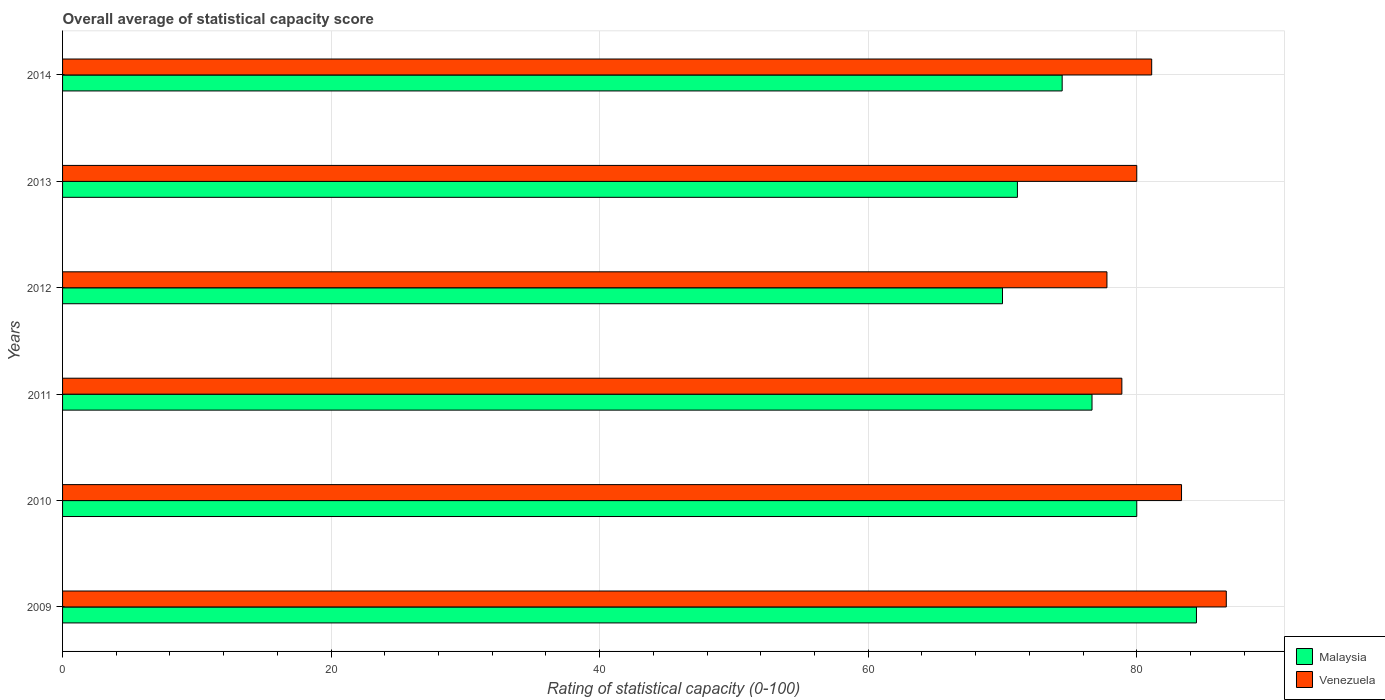How many different coloured bars are there?
Ensure brevity in your answer.  2. Are the number of bars per tick equal to the number of legend labels?
Make the answer very short. Yes. How many bars are there on the 3rd tick from the top?
Your response must be concise. 2. How many bars are there on the 2nd tick from the bottom?
Offer a very short reply. 2. What is the label of the 5th group of bars from the top?
Keep it short and to the point. 2010. What is the rating of statistical capacity in Venezuela in 2009?
Provide a short and direct response. 86.67. Across all years, what is the maximum rating of statistical capacity in Venezuela?
Offer a very short reply. 86.67. Across all years, what is the minimum rating of statistical capacity in Venezuela?
Make the answer very short. 77.78. In which year was the rating of statistical capacity in Malaysia minimum?
Offer a terse response. 2012. What is the total rating of statistical capacity in Venezuela in the graph?
Give a very brief answer. 487.78. What is the difference between the rating of statistical capacity in Malaysia in 2010 and that in 2013?
Keep it short and to the point. 8.89. What is the difference between the rating of statistical capacity in Venezuela in 2011 and the rating of statistical capacity in Malaysia in 2012?
Offer a terse response. 8.89. What is the average rating of statistical capacity in Venezuela per year?
Ensure brevity in your answer.  81.3. In the year 2010, what is the difference between the rating of statistical capacity in Malaysia and rating of statistical capacity in Venezuela?
Provide a short and direct response. -3.33. In how many years, is the rating of statistical capacity in Venezuela greater than 56 ?
Your answer should be compact. 6. What is the ratio of the rating of statistical capacity in Venezuela in 2010 to that in 2014?
Provide a succinct answer. 1.03. Is the rating of statistical capacity in Venezuela in 2010 less than that in 2014?
Offer a terse response. No. Is the difference between the rating of statistical capacity in Malaysia in 2011 and 2014 greater than the difference between the rating of statistical capacity in Venezuela in 2011 and 2014?
Ensure brevity in your answer.  Yes. What is the difference between the highest and the second highest rating of statistical capacity in Malaysia?
Your answer should be very brief. 4.44. What is the difference between the highest and the lowest rating of statistical capacity in Malaysia?
Your response must be concise. 14.44. Is the sum of the rating of statistical capacity in Venezuela in 2011 and 2013 greater than the maximum rating of statistical capacity in Malaysia across all years?
Provide a succinct answer. Yes. What does the 1st bar from the top in 2012 represents?
Give a very brief answer. Venezuela. What does the 1st bar from the bottom in 2013 represents?
Your answer should be compact. Malaysia. How many bars are there?
Provide a short and direct response. 12. Are all the bars in the graph horizontal?
Provide a succinct answer. Yes. How many years are there in the graph?
Offer a terse response. 6. Are the values on the major ticks of X-axis written in scientific E-notation?
Your answer should be very brief. No. Where does the legend appear in the graph?
Your response must be concise. Bottom right. What is the title of the graph?
Ensure brevity in your answer.  Overall average of statistical capacity score. Does "Cambodia" appear as one of the legend labels in the graph?
Your answer should be compact. No. What is the label or title of the X-axis?
Keep it short and to the point. Rating of statistical capacity (0-100). What is the label or title of the Y-axis?
Your response must be concise. Years. What is the Rating of statistical capacity (0-100) of Malaysia in 2009?
Your response must be concise. 84.44. What is the Rating of statistical capacity (0-100) in Venezuela in 2009?
Ensure brevity in your answer.  86.67. What is the Rating of statistical capacity (0-100) of Venezuela in 2010?
Your answer should be very brief. 83.33. What is the Rating of statistical capacity (0-100) of Malaysia in 2011?
Provide a short and direct response. 76.67. What is the Rating of statistical capacity (0-100) in Venezuela in 2011?
Keep it short and to the point. 78.89. What is the Rating of statistical capacity (0-100) in Malaysia in 2012?
Your answer should be very brief. 70. What is the Rating of statistical capacity (0-100) in Venezuela in 2012?
Your answer should be very brief. 77.78. What is the Rating of statistical capacity (0-100) of Malaysia in 2013?
Provide a succinct answer. 71.11. What is the Rating of statistical capacity (0-100) in Malaysia in 2014?
Your answer should be compact. 74.44. What is the Rating of statistical capacity (0-100) of Venezuela in 2014?
Your answer should be very brief. 81.11. Across all years, what is the maximum Rating of statistical capacity (0-100) of Malaysia?
Your answer should be very brief. 84.44. Across all years, what is the maximum Rating of statistical capacity (0-100) in Venezuela?
Your answer should be very brief. 86.67. Across all years, what is the minimum Rating of statistical capacity (0-100) of Malaysia?
Your response must be concise. 70. Across all years, what is the minimum Rating of statistical capacity (0-100) in Venezuela?
Make the answer very short. 77.78. What is the total Rating of statistical capacity (0-100) of Malaysia in the graph?
Offer a terse response. 456.67. What is the total Rating of statistical capacity (0-100) of Venezuela in the graph?
Provide a short and direct response. 487.78. What is the difference between the Rating of statistical capacity (0-100) in Malaysia in 2009 and that in 2010?
Offer a very short reply. 4.44. What is the difference between the Rating of statistical capacity (0-100) of Venezuela in 2009 and that in 2010?
Offer a terse response. 3.33. What is the difference between the Rating of statistical capacity (0-100) in Malaysia in 2009 and that in 2011?
Make the answer very short. 7.78. What is the difference between the Rating of statistical capacity (0-100) in Venezuela in 2009 and that in 2011?
Offer a terse response. 7.78. What is the difference between the Rating of statistical capacity (0-100) in Malaysia in 2009 and that in 2012?
Provide a succinct answer. 14.44. What is the difference between the Rating of statistical capacity (0-100) in Venezuela in 2009 and that in 2012?
Ensure brevity in your answer.  8.89. What is the difference between the Rating of statistical capacity (0-100) in Malaysia in 2009 and that in 2013?
Offer a very short reply. 13.33. What is the difference between the Rating of statistical capacity (0-100) in Venezuela in 2009 and that in 2013?
Offer a very short reply. 6.67. What is the difference between the Rating of statistical capacity (0-100) of Venezuela in 2009 and that in 2014?
Your response must be concise. 5.56. What is the difference between the Rating of statistical capacity (0-100) of Malaysia in 2010 and that in 2011?
Provide a short and direct response. 3.33. What is the difference between the Rating of statistical capacity (0-100) of Venezuela in 2010 and that in 2011?
Your response must be concise. 4.44. What is the difference between the Rating of statistical capacity (0-100) of Venezuela in 2010 and that in 2012?
Your answer should be compact. 5.56. What is the difference between the Rating of statistical capacity (0-100) in Malaysia in 2010 and that in 2013?
Keep it short and to the point. 8.89. What is the difference between the Rating of statistical capacity (0-100) in Malaysia in 2010 and that in 2014?
Offer a terse response. 5.56. What is the difference between the Rating of statistical capacity (0-100) of Venezuela in 2010 and that in 2014?
Ensure brevity in your answer.  2.22. What is the difference between the Rating of statistical capacity (0-100) of Venezuela in 2011 and that in 2012?
Keep it short and to the point. 1.11. What is the difference between the Rating of statistical capacity (0-100) of Malaysia in 2011 and that in 2013?
Give a very brief answer. 5.56. What is the difference between the Rating of statistical capacity (0-100) in Venezuela in 2011 and that in 2013?
Provide a short and direct response. -1.11. What is the difference between the Rating of statistical capacity (0-100) in Malaysia in 2011 and that in 2014?
Ensure brevity in your answer.  2.22. What is the difference between the Rating of statistical capacity (0-100) in Venezuela in 2011 and that in 2014?
Your answer should be very brief. -2.22. What is the difference between the Rating of statistical capacity (0-100) of Malaysia in 2012 and that in 2013?
Provide a succinct answer. -1.11. What is the difference between the Rating of statistical capacity (0-100) in Venezuela in 2012 and that in 2013?
Ensure brevity in your answer.  -2.22. What is the difference between the Rating of statistical capacity (0-100) of Malaysia in 2012 and that in 2014?
Keep it short and to the point. -4.44. What is the difference between the Rating of statistical capacity (0-100) in Malaysia in 2013 and that in 2014?
Give a very brief answer. -3.33. What is the difference between the Rating of statistical capacity (0-100) in Venezuela in 2013 and that in 2014?
Make the answer very short. -1.11. What is the difference between the Rating of statistical capacity (0-100) of Malaysia in 2009 and the Rating of statistical capacity (0-100) of Venezuela in 2011?
Ensure brevity in your answer.  5.56. What is the difference between the Rating of statistical capacity (0-100) in Malaysia in 2009 and the Rating of statistical capacity (0-100) in Venezuela in 2012?
Keep it short and to the point. 6.67. What is the difference between the Rating of statistical capacity (0-100) in Malaysia in 2009 and the Rating of statistical capacity (0-100) in Venezuela in 2013?
Make the answer very short. 4.44. What is the difference between the Rating of statistical capacity (0-100) of Malaysia in 2009 and the Rating of statistical capacity (0-100) of Venezuela in 2014?
Ensure brevity in your answer.  3.33. What is the difference between the Rating of statistical capacity (0-100) in Malaysia in 2010 and the Rating of statistical capacity (0-100) in Venezuela in 2011?
Keep it short and to the point. 1.11. What is the difference between the Rating of statistical capacity (0-100) in Malaysia in 2010 and the Rating of statistical capacity (0-100) in Venezuela in 2012?
Your answer should be compact. 2.22. What is the difference between the Rating of statistical capacity (0-100) in Malaysia in 2010 and the Rating of statistical capacity (0-100) in Venezuela in 2014?
Keep it short and to the point. -1.11. What is the difference between the Rating of statistical capacity (0-100) of Malaysia in 2011 and the Rating of statistical capacity (0-100) of Venezuela in 2012?
Make the answer very short. -1.11. What is the difference between the Rating of statistical capacity (0-100) in Malaysia in 2011 and the Rating of statistical capacity (0-100) in Venezuela in 2014?
Ensure brevity in your answer.  -4.44. What is the difference between the Rating of statistical capacity (0-100) in Malaysia in 2012 and the Rating of statistical capacity (0-100) in Venezuela in 2013?
Your response must be concise. -10. What is the difference between the Rating of statistical capacity (0-100) in Malaysia in 2012 and the Rating of statistical capacity (0-100) in Venezuela in 2014?
Provide a short and direct response. -11.11. What is the average Rating of statistical capacity (0-100) in Malaysia per year?
Your answer should be compact. 76.11. What is the average Rating of statistical capacity (0-100) in Venezuela per year?
Provide a succinct answer. 81.3. In the year 2009, what is the difference between the Rating of statistical capacity (0-100) of Malaysia and Rating of statistical capacity (0-100) of Venezuela?
Your answer should be very brief. -2.22. In the year 2010, what is the difference between the Rating of statistical capacity (0-100) of Malaysia and Rating of statistical capacity (0-100) of Venezuela?
Provide a succinct answer. -3.33. In the year 2011, what is the difference between the Rating of statistical capacity (0-100) in Malaysia and Rating of statistical capacity (0-100) in Venezuela?
Make the answer very short. -2.22. In the year 2012, what is the difference between the Rating of statistical capacity (0-100) in Malaysia and Rating of statistical capacity (0-100) in Venezuela?
Provide a succinct answer. -7.78. In the year 2013, what is the difference between the Rating of statistical capacity (0-100) in Malaysia and Rating of statistical capacity (0-100) in Venezuela?
Your answer should be very brief. -8.89. In the year 2014, what is the difference between the Rating of statistical capacity (0-100) of Malaysia and Rating of statistical capacity (0-100) of Venezuela?
Keep it short and to the point. -6.67. What is the ratio of the Rating of statistical capacity (0-100) of Malaysia in 2009 to that in 2010?
Offer a very short reply. 1.06. What is the ratio of the Rating of statistical capacity (0-100) in Venezuela in 2009 to that in 2010?
Provide a succinct answer. 1.04. What is the ratio of the Rating of statistical capacity (0-100) of Malaysia in 2009 to that in 2011?
Offer a very short reply. 1.1. What is the ratio of the Rating of statistical capacity (0-100) of Venezuela in 2009 to that in 2011?
Give a very brief answer. 1.1. What is the ratio of the Rating of statistical capacity (0-100) of Malaysia in 2009 to that in 2012?
Your answer should be very brief. 1.21. What is the ratio of the Rating of statistical capacity (0-100) in Venezuela in 2009 to that in 2012?
Offer a very short reply. 1.11. What is the ratio of the Rating of statistical capacity (0-100) of Malaysia in 2009 to that in 2013?
Give a very brief answer. 1.19. What is the ratio of the Rating of statistical capacity (0-100) in Venezuela in 2009 to that in 2013?
Your answer should be very brief. 1.08. What is the ratio of the Rating of statistical capacity (0-100) in Malaysia in 2009 to that in 2014?
Offer a terse response. 1.13. What is the ratio of the Rating of statistical capacity (0-100) of Venezuela in 2009 to that in 2014?
Ensure brevity in your answer.  1.07. What is the ratio of the Rating of statistical capacity (0-100) of Malaysia in 2010 to that in 2011?
Keep it short and to the point. 1.04. What is the ratio of the Rating of statistical capacity (0-100) of Venezuela in 2010 to that in 2011?
Keep it short and to the point. 1.06. What is the ratio of the Rating of statistical capacity (0-100) of Malaysia in 2010 to that in 2012?
Provide a succinct answer. 1.14. What is the ratio of the Rating of statistical capacity (0-100) of Venezuela in 2010 to that in 2012?
Your answer should be very brief. 1.07. What is the ratio of the Rating of statistical capacity (0-100) of Venezuela in 2010 to that in 2013?
Your response must be concise. 1.04. What is the ratio of the Rating of statistical capacity (0-100) in Malaysia in 2010 to that in 2014?
Your response must be concise. 1.07. What is the ratio of the Rating of statistical capacity (0-100) of Venezuela in 2010 to that in 2014?
Provide a succinct answer. 1.03. What is the ratio of the Rating of statistical capacity (0-100) in Malaysia in 2011 to that in 2012?
Provide a succinct answer. 1.1. What is the ratio of the Rating of statistical capacity (0-100) in Venezuela in 2011 to that in 2012?
Offer a very short reply. 1.01. What is the ratio of the Rating of statistical capacity (0-100) in Malaysia in 2011 to that in 2013?
Make the answer very short. 1.08. What is the ratio of the Rating of statistical capacity (0-100) in Venezuela in 2011 to that in 2013?
Provide a succinct answer. 0.99. What is the ratio of the Rating of statistical capacity (0-100) of Malaysia in 2011 to that in 2014?
Your response must be concise. 1.03. What is the ratio of the Rating of statistical capacity (0-100) in Venezuela in 2011 to that in 2014?
Provide a succinct answer. 0.97. What is the ratio of the Rating of statistical capacity (0-100) of Malaysia in 2012 to that in 2013?
Provide a succinct answer. 0.98. What is the ratio of the Rating of statistical capacity (0-100) of Venezuela in 2012 to that in 2013?
Offer a terse response. 0.97. What is the ratio of the Rating of statistical capacity (0-100) of Malaysia in 2012 to that in 2014?
Keep it short and to the point. 0.94. What is the ratio of the Rating of statistical capacity (0-100) of Venezuela in 2012 to that in 2014?
Provide a succinct answer. 0.96. What is the ratio of the Rating of statistical capacity (0-100) in Malaysia in 2013 to that in 2014?
Ensure brevity in your answer.  0.96. What is the ratio of the Rating of statistical capacity (0-100) in Venezuela in 2013 to that in 2014?
Your response must be concise. 0.99. What is the difference between the highest and the second highest Rating of statistical capacity (0-100) in Malaysia?
Offer a terse response. 4.44. What is the difference between the highest and the lowest Rating of statistical capacity (0-100) of Malaysia?
Give a very brief answer. 14.44. What is the difference between the highest and the lowest Rating of statistical capacity (0-100) of Venezuela?
Your answer should be very brief. 8.89. 